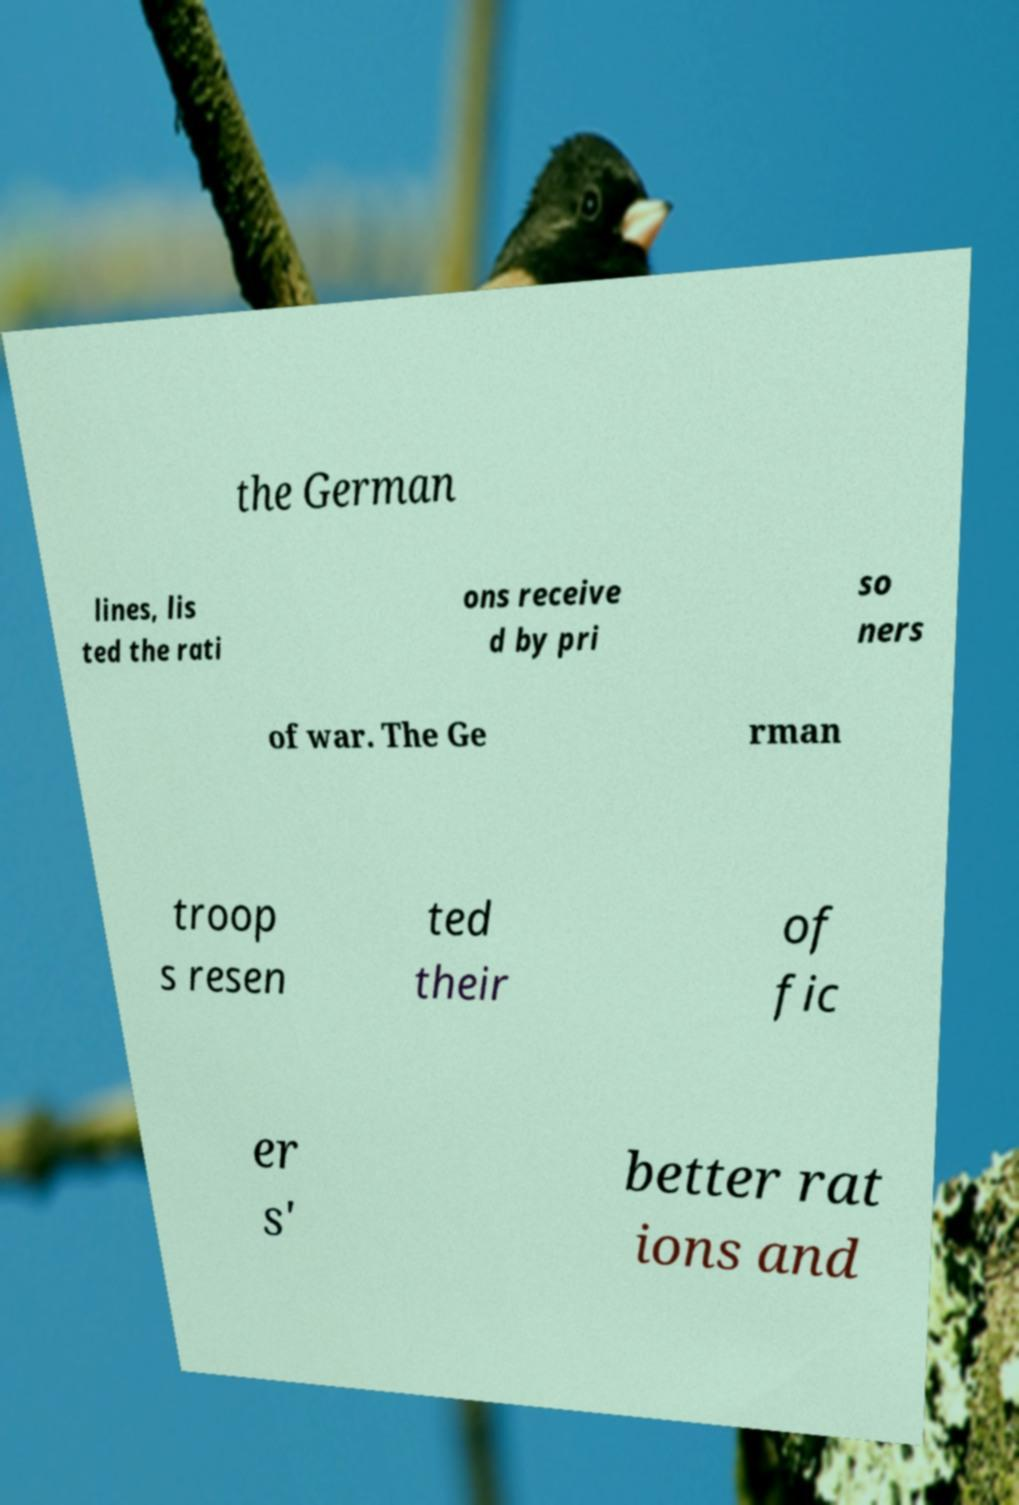What messages or text are displayed in this image? I need them in a readable, typed format. the German lines, lis ted the rati ons receive d by pri so ners of war. The Ge rman troop s resen ted their of fic er s' better rat ions and 